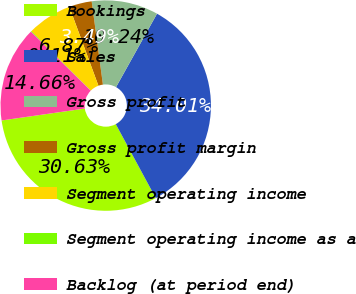<chart> <loc_0><loc_0><loc_500><loc_500><pie_chart><fcel>Bookings<fcel>Sales<fcel>Gross profit<fcel>Gross profit margin<fcel>Segment operating income<fcel>Segment operating income as a<fcel>Backlog (at period end)<nl><fcel>30.63%<fcel>34.01%<fcel>10.24%<fcel>3.49%<fcel>6.87%<fcel>0.11%<fcel>14.66%<nl></chart> 